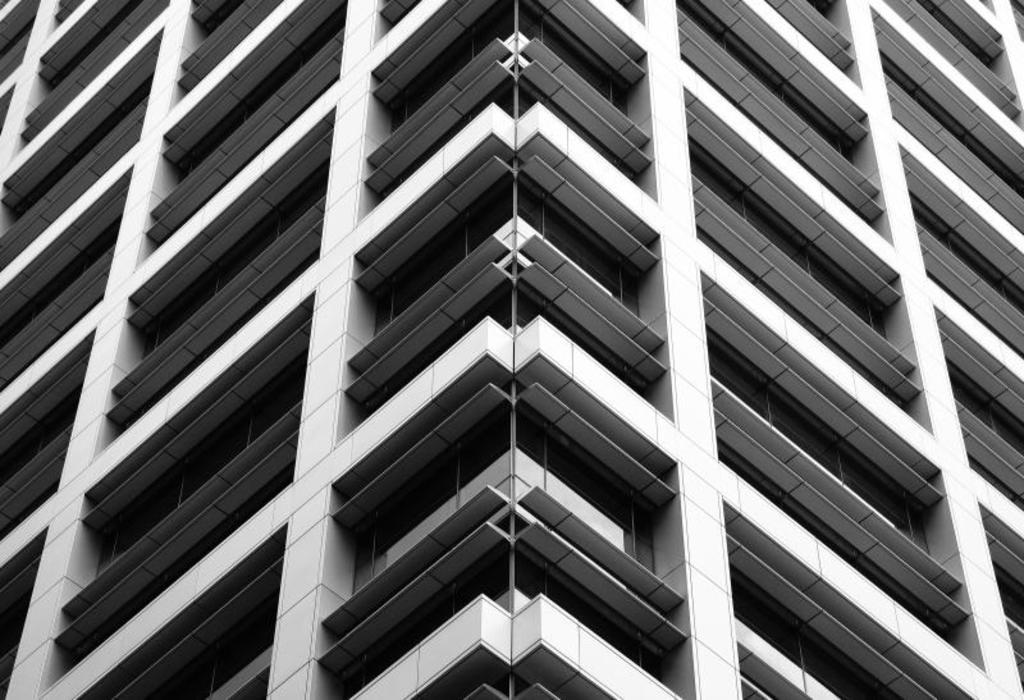What type of structure is visible in the image? There is a building in the image. What type of tax is being discussed on the stage in the image? There is no stage or tax present in the image; it only features a building. How many cakes are visible on the building in the image? There are no cakes present in the image; it only features a building. 